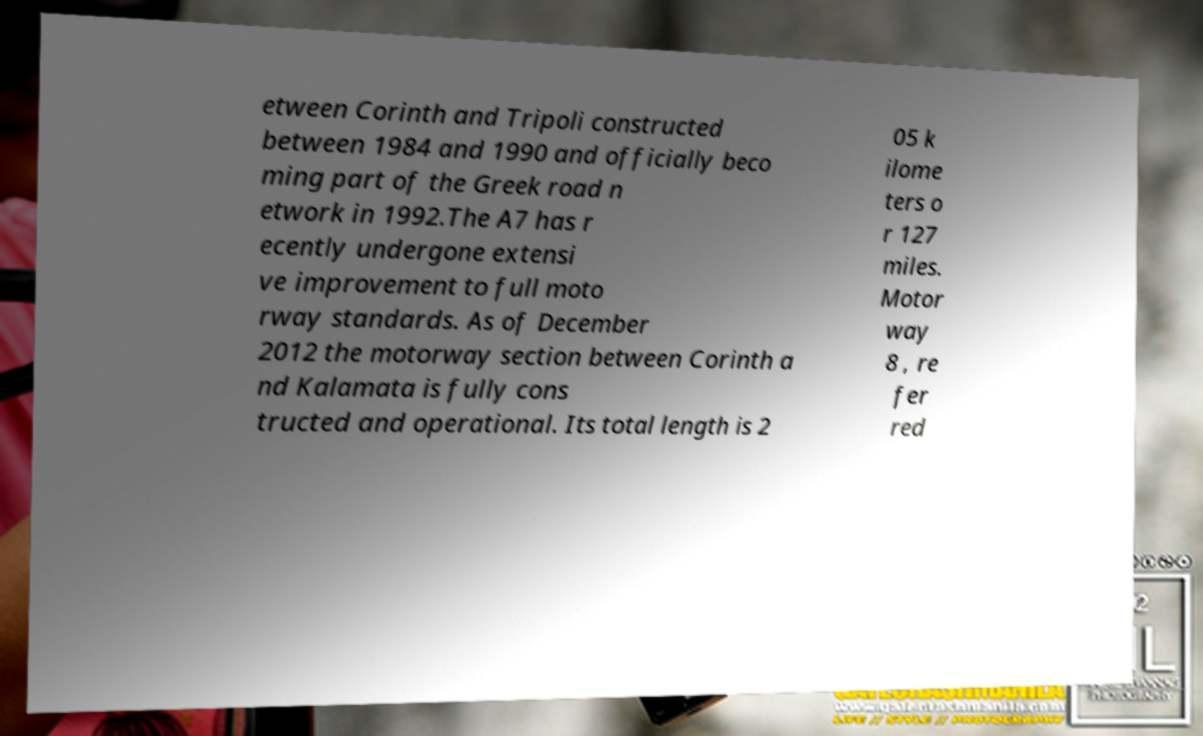I need the written content from this picture converted into text. Can you do that? etween Corinth and Tripoli constructed between 1984 and 1990 and officially beco ming part of the Greek road n etwork in 1992.The A7 has r ecently undergone extensi ve improvement to full moto rway standards. As of December 2012 the motorway section between Corinth a nd Kalamata is fully cons tructed and operational. Its total length is 2 05 k ilome ters o r 127 miles. Motor way 8 , re fer red 